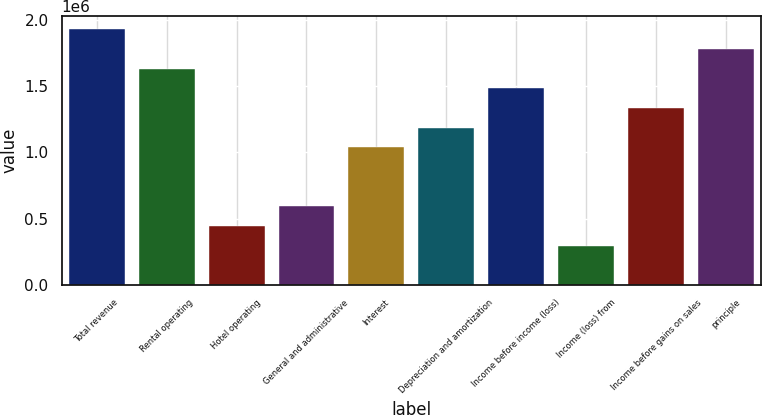Convert chart to OTSL. <chart><loc_0><loc_0><loc_500><loc_500><bar_chart><fcel>Total revenue<fcel>Rental operating<fcel>Hotel operating<fcel>General and administrative<fcel>Interest<fcel>Depreciation and amortization<fcel>Income before income (loss)<fcel>Income (loss) from<fcel>Income before gains on sales<fcel>principle<nl><fcel>1.92697e+06<fcel>1.63052e+06<fcel>444693<fcel>592921<fcel>1.03761e+06<fcel>1.18583e+06<fcel>1.48229e+06<fcel>296465<fcel>1.33406e+06<fcel>1.77874e+06<nl></chart> 